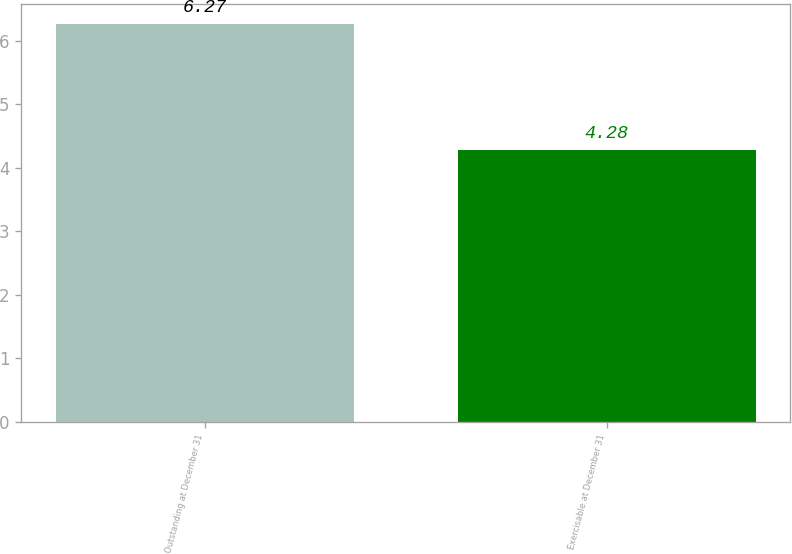Convert chart to OTSL. <chart><loc_0><loc_0><loc_500><loc_500><bar_chart><fcel>Outstanding at December 31<fcel>Exercisable at December 31<nl><fcel>6.27<fcel>4.28<nl></chart> 